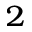<formula> <loc_0><loc_0><loc_500><loc_500>_ { 2 }</formula> 